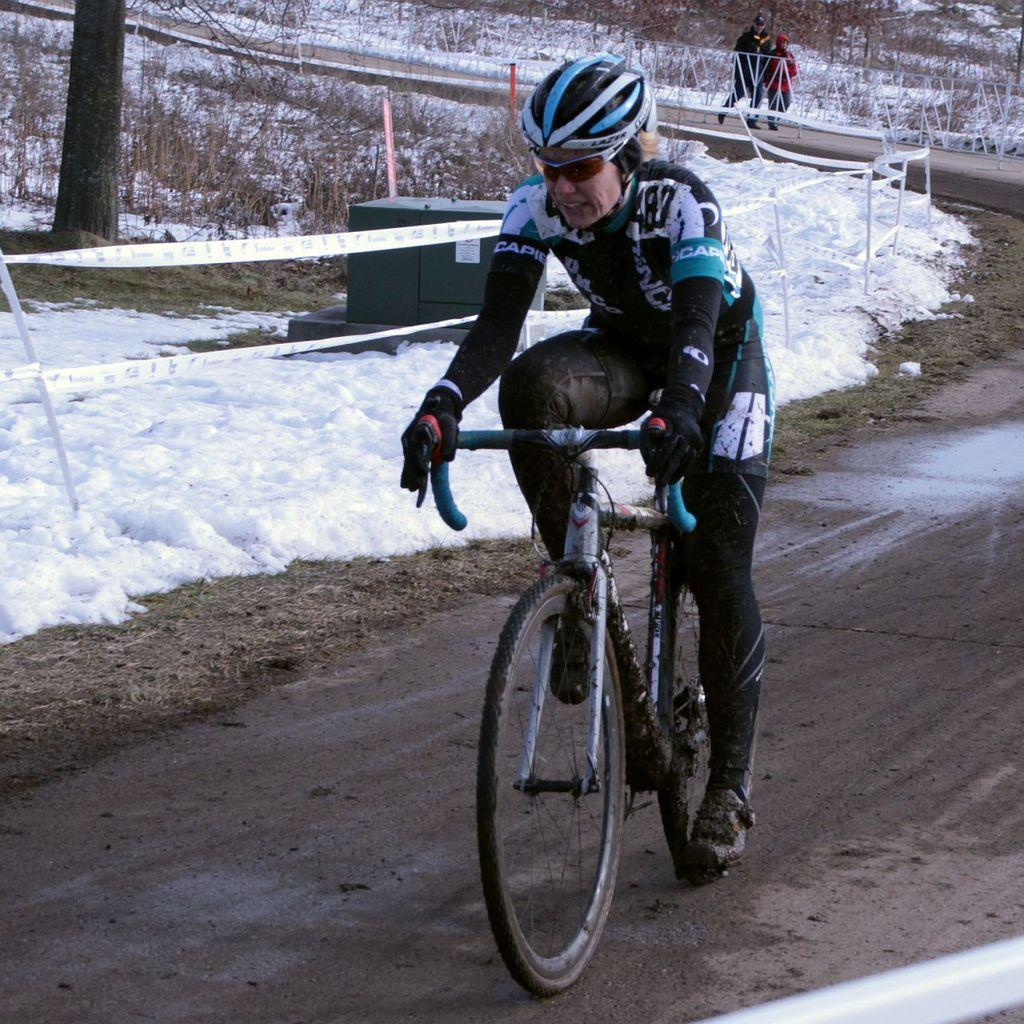What is the person in the image doing? The person is riding a bicycle in the image. Where is the person riding the bicycle? The person is on the road. What is the weather like in the image? There is snow visible in the image, indicating a cold or wintry weather. What can be seen in the background of the image? There are trees in the image. What type of cake is being served on the silk tablecloth in the image? There is no cake or silk tablecloth present in the image. Can you describe the insect that is crawling on the person's shoulder in the image? There is no insect visible on the person's shoulder in the image. 